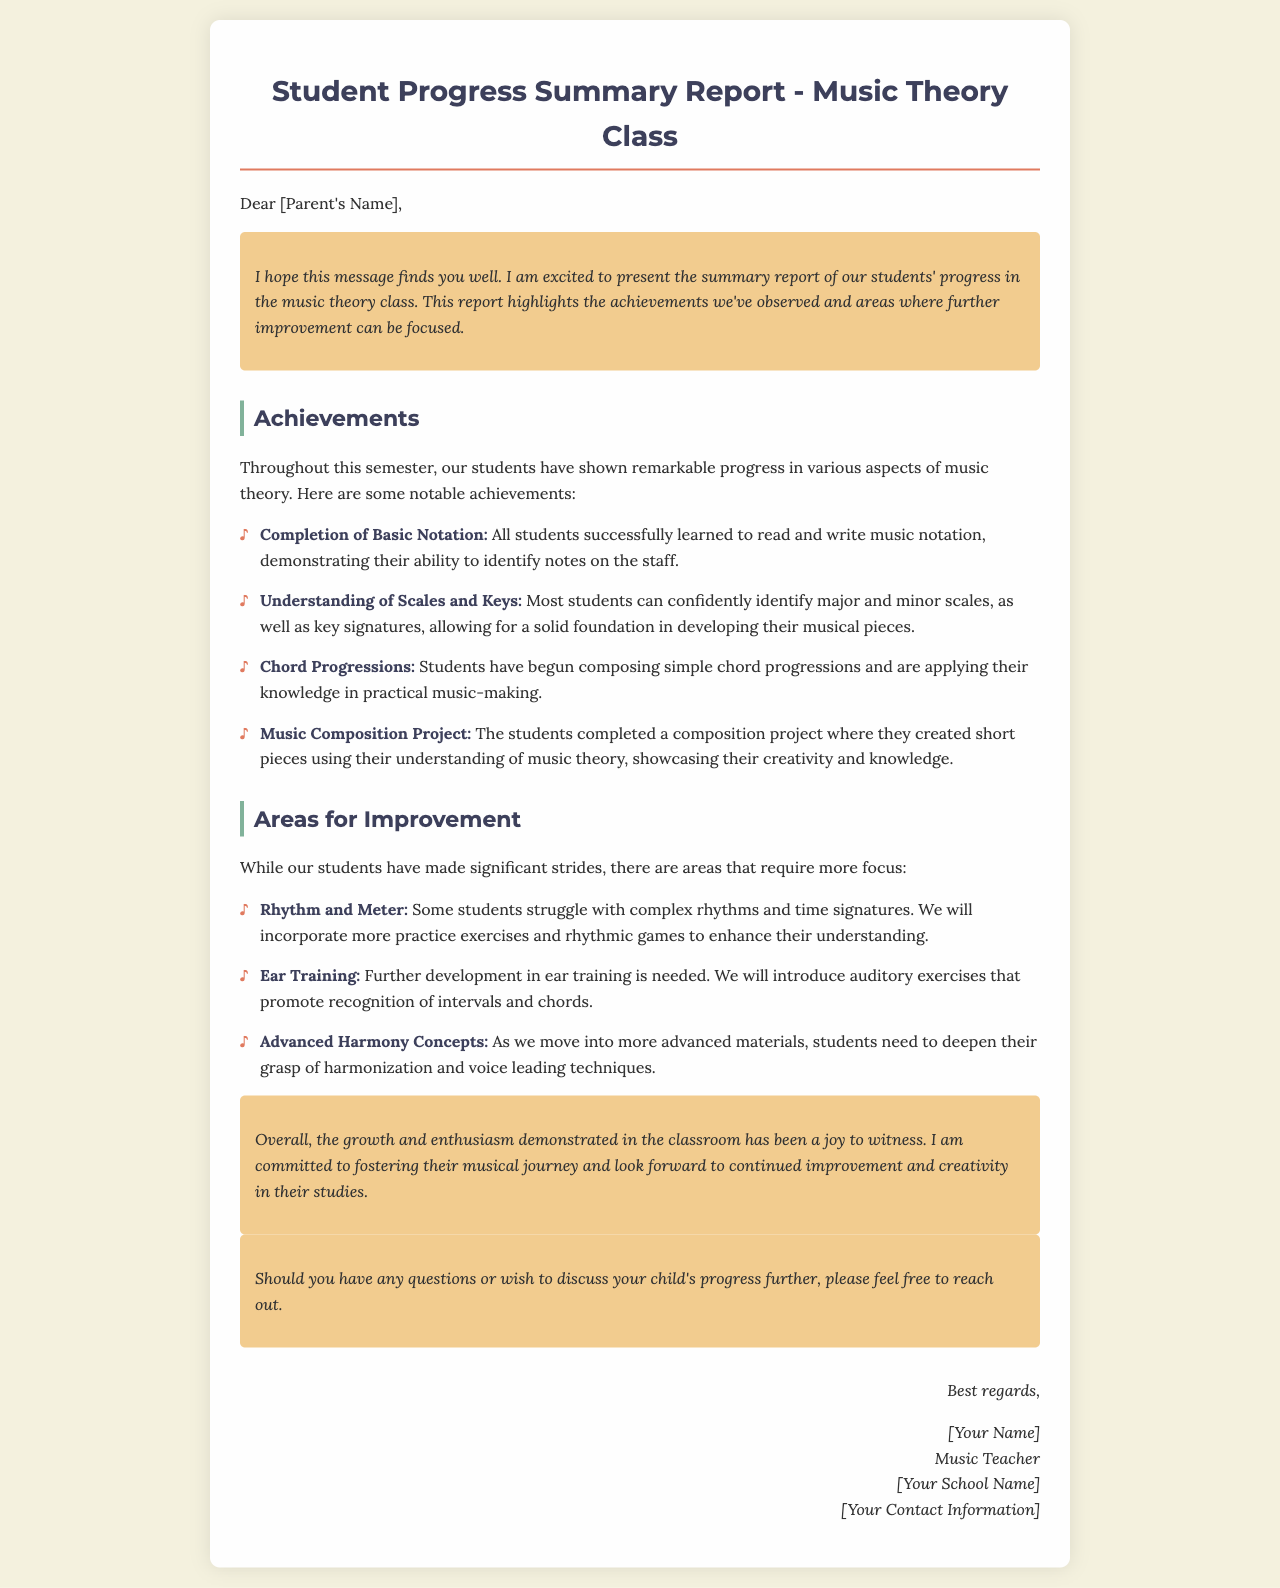What is the title of the report? The title of the report is presented prominently at the top of the document, which indicates its purpose.
Answer: Student Progress Summary Report - Music Theory Class What color is used for the achievements section? The document uses specific colors for different sections to enhance visual engagement; the achievements section's heading is in a darker shade.
Answer: #3d405b What is one of the notable achievements mentioned? The report lists specific notable achievements that highlight student successes in music theory.
Answer: Completion of Basic Notation What area for improvement relates to complex rhythms? The document clearly outlines areas where students need to focus more attention, specifically mentioning timely concepts.
Answer: Rhythm and Meter How does the teacher encourage further communication? The document includes a section that promotes dialogue between the teacher and parents, indicating openness to questions.
Answer: Should you have any questions or wish to discuss your child's progress further, please feel free to reach out What is the teacher's signature style? The signature follows a specific format that adds a personal touch to the communication, enhancing its authenticity.
Answer: Italic style What is the background color of the document? The background color is important for the visual design of the document, making it appear inviting and readable.
Answer: #f4f1de 